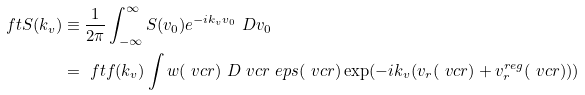<formula> <loc_0><loc_0><loc_500><loc_500>\ f t { S } ( k _ { v } ) & \equiv \frac { 1 } { 2 \pi } \int _ { - \infty } ^ { \infty } S ( v _ { 0 } ) e ^ { - i k _ { v } v _ { 0 } } \ D { v _ { 0 } } \\ & = \ f t { f } ( k _ { v } ) \int w ( \ v c { r } ) \ D { \ v c { r } } \ e p s ( \ v c { r } ) \exp ( - i k _ { v } ( v _ { r } ( \ v c { r } ) + v _ { r } ^ { r e g } ( \ v c { r } ) ) )</formula> 